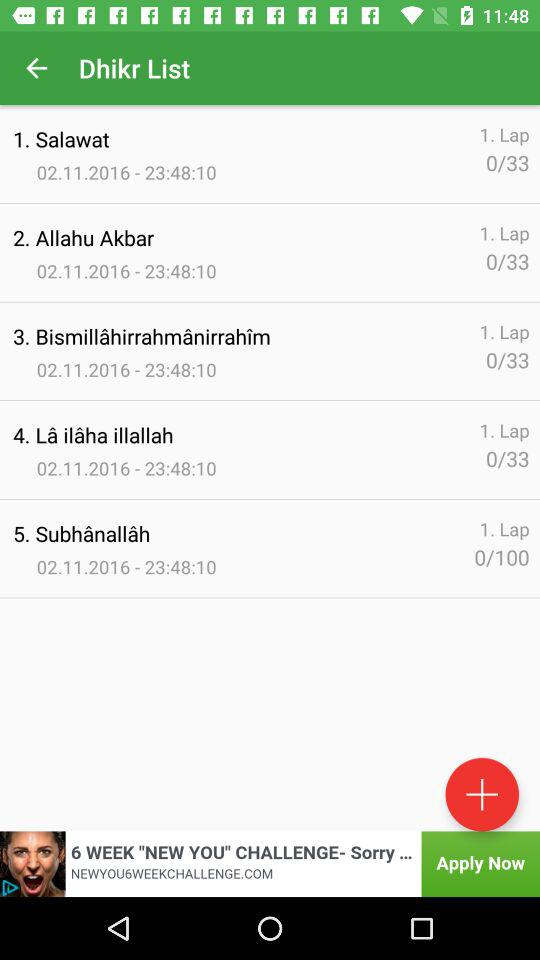What is the name of the list? The name of the list is "Dhikr". 